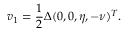<formula> <loc_0><loc_0><loc_500><loc_500>v _ { 1 } = \frac { 1 } { 2 } \Delta ( 0 , 0 , \eta , - \nu ) ^ { T } .</formula> 